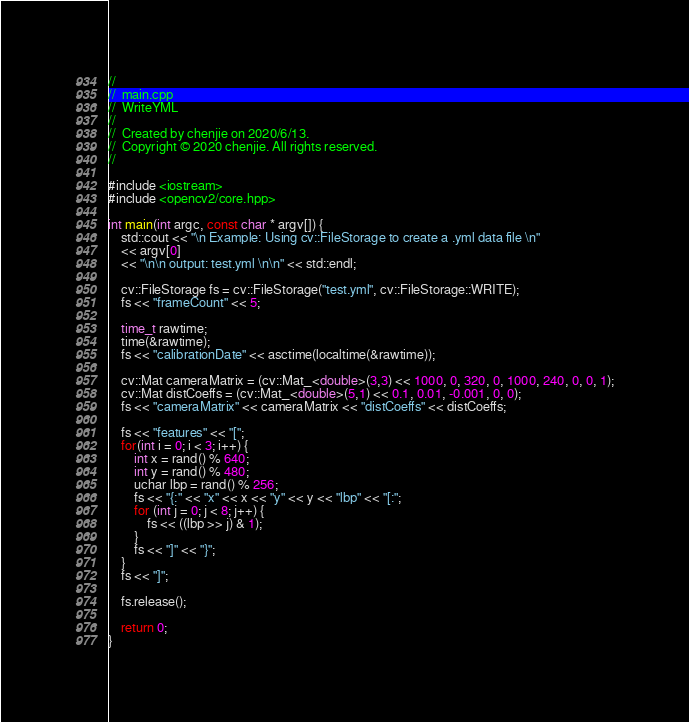Convert code to text. <code><loc_0><loc_0><loc_500><loc_500><_C++_>//
//  main.cpp
//  WriteYML
//
//  Created by chenjie on 2020/6/13.
//  Copyright © 2020 chenjie. All rights reserved.
//

#include <iostream>
#include <opencv2/core.hpp>

int main(int argc, const char * argv[]) {
    std::cout << "\n Example: Using cv::FileStorage to create a .yml data file \n"
    << argv[0]
    << "\n\n output: test.yml \n\n" << std::endl;
    
    cv::FileStorage fs = cv::FileStorage("test.yml", cv::FileStorage::WRITE);
    fs << "frameCount" << 5;

    time_t rawtime;
    time(&rawtime);
    fs << "calibrationDate" << asctime(localtime(&rawtime));

    cv::Mat cameraMatrix = (cv::Mat_<double>(3,3) << 1000, 0, 320, 0, 1000, 240, 0, 0, 1);
    cv::Mat distCoeffs = (cv::Mat_<double>(5,1) << 0.1, 0.01, -0.001, 0, 0);
    fs << "cameraMatrix" << cameraMatrix << "distCoeffs" << distCoeffs;
    
    fs << "features" << "[";
    for(int i = 0; i < 3; i++) {
        int x = rand() % 640;
        int y = rand() % 480;
        uchar lbp = rand() % 256;
        fs << "{:" << "x" << x << "y" << y << "lbp" << "[:";
        for (int j = 0; j < 8; j++) {
            fs << ((lbp >> j) & 1);
        }
        fs << "]" << "}";
    }
    fs << "]";

    fs.release();
    
    return 0;
}
</code> 